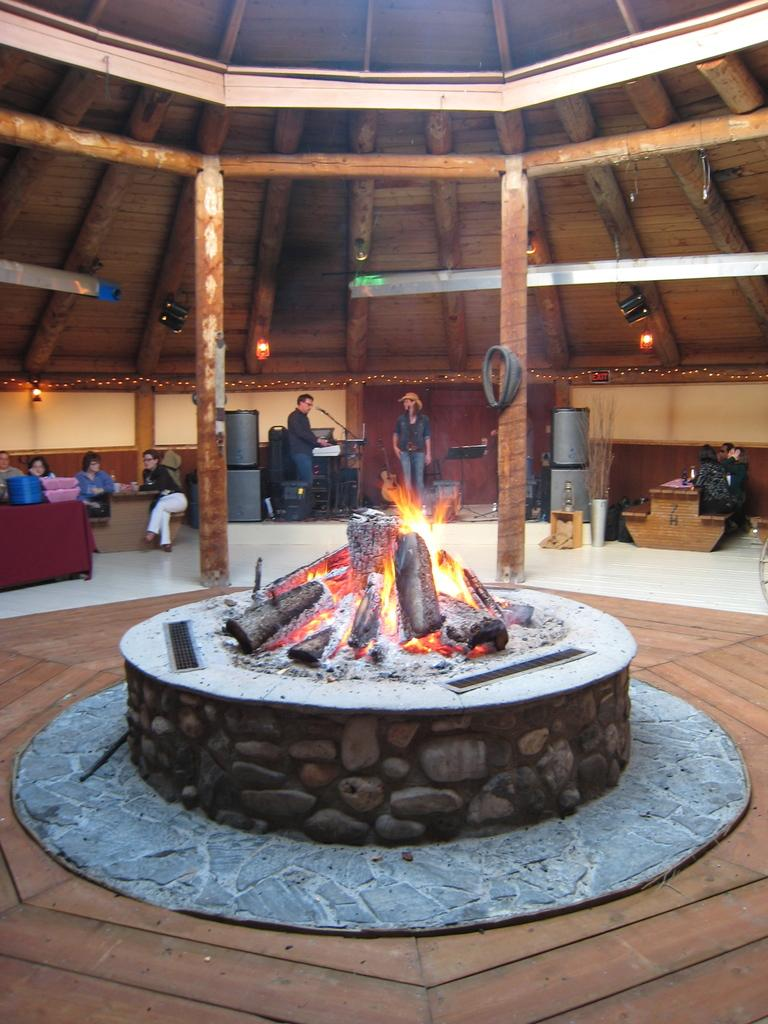How many people are in the image? There are persons in the image, but the exact number is not specified. What can be seen illuminating the scene in the image? There are lights in the image. What type of furniture is present in the image? There are tables in the image. What is the source of heat or light in the image? There is fire in the image. What type of vertical structures are present in the image? There are poles in the image. Is there a maid cleaning the floor in the image? There is no mention of a maid or cleaning activity in the image. Is it raining in the image? There is no mention of rain or any weather conditions in the image. 